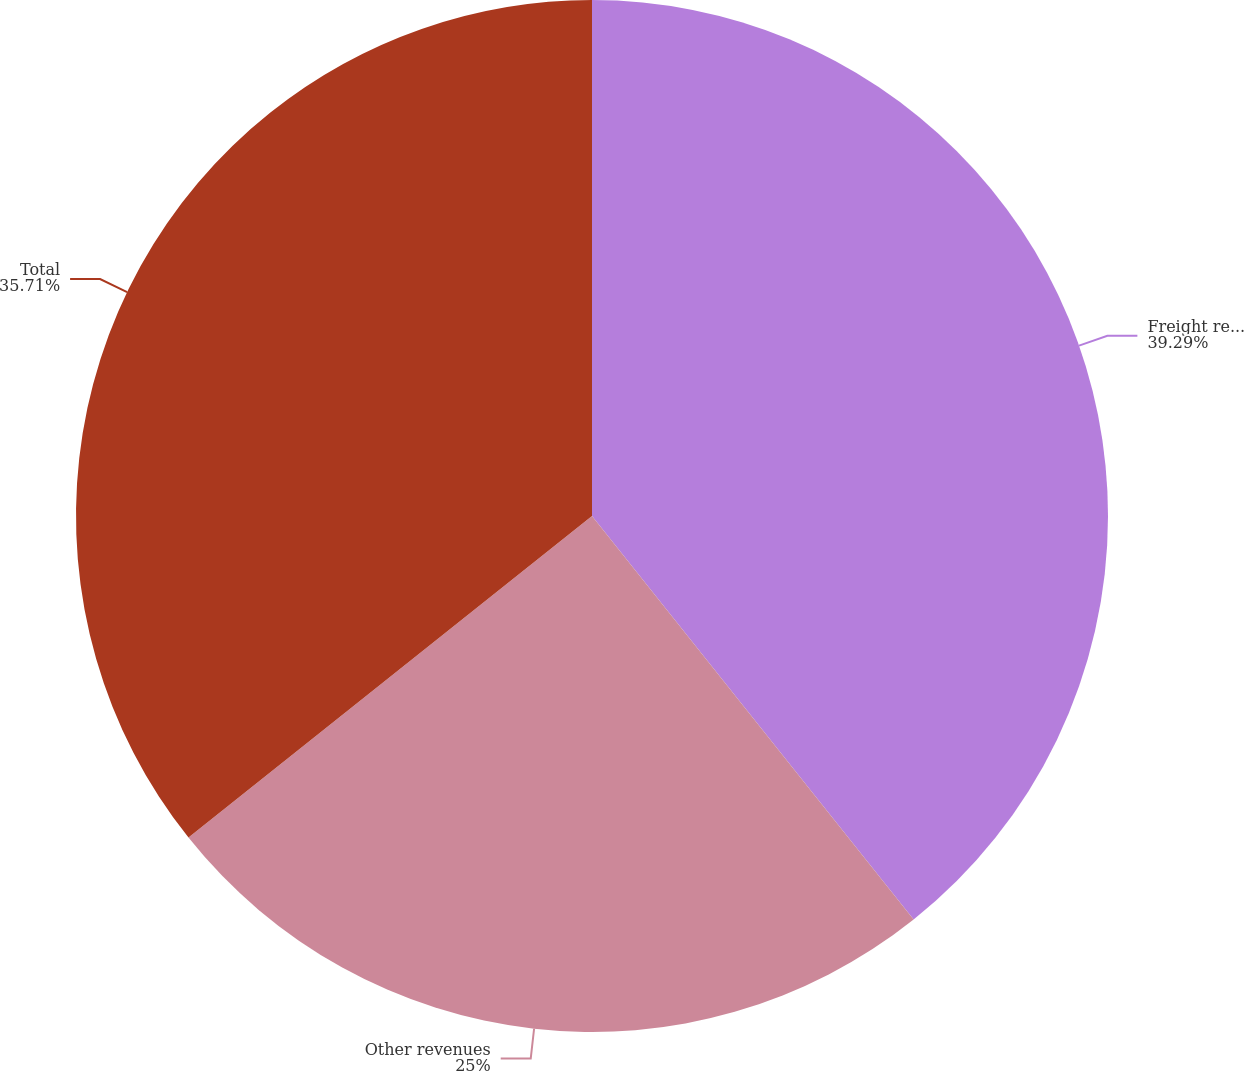Convert chart. <chart><loc_0><loc_0><loc_500><loc_500><pie_chart><fcel>Freight revenues<fcel>Other revenues<fcel>Total<nl><fcel>39.29%<fcel>25.0%<fcel>35.71%<nl></chart> 